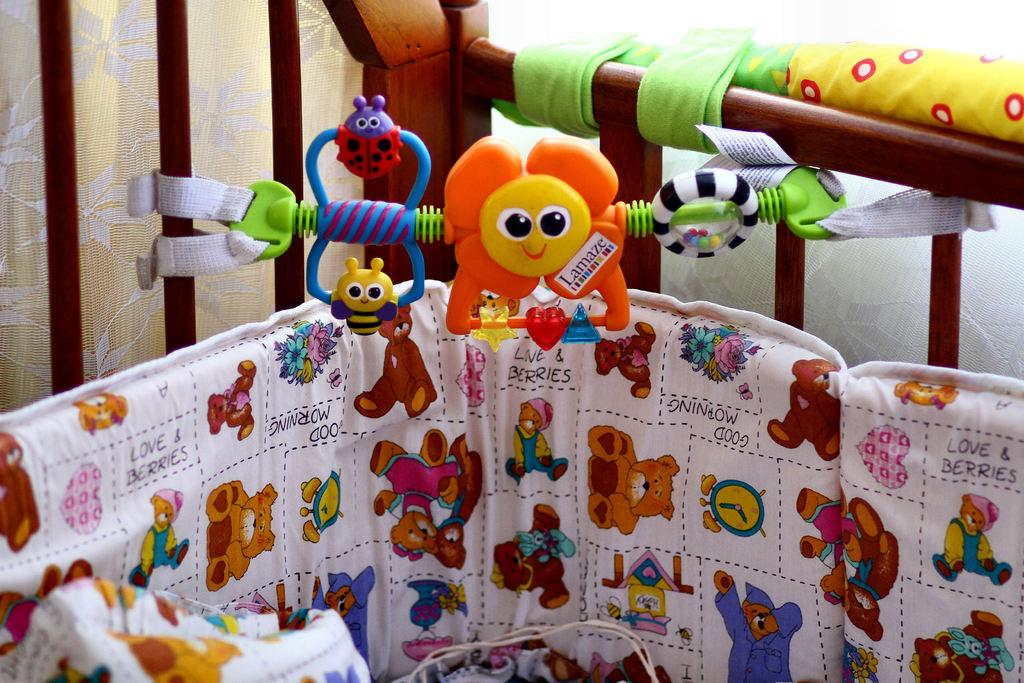What is the main object in the image? There is a cradle in the image. What can be found inside the cradle? There are toys in the cradle. What is visible in the background of the image? There are curtains in the background of the image. How far away is the bean from the birthday celebration in the image? There is no bean or birthday celebration present in the image. 